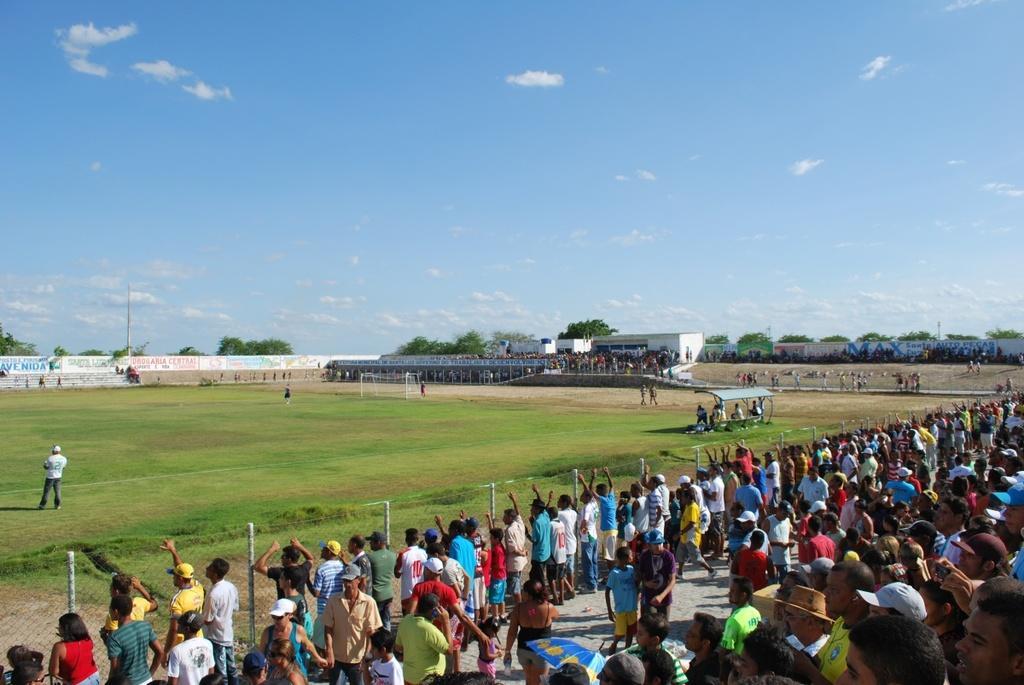Could you give a brief overview of what you see in this image? As we can see in the image there are group of people standing here and there. There is fence, grass, buildings, trees, current pole, sky and clouds. 